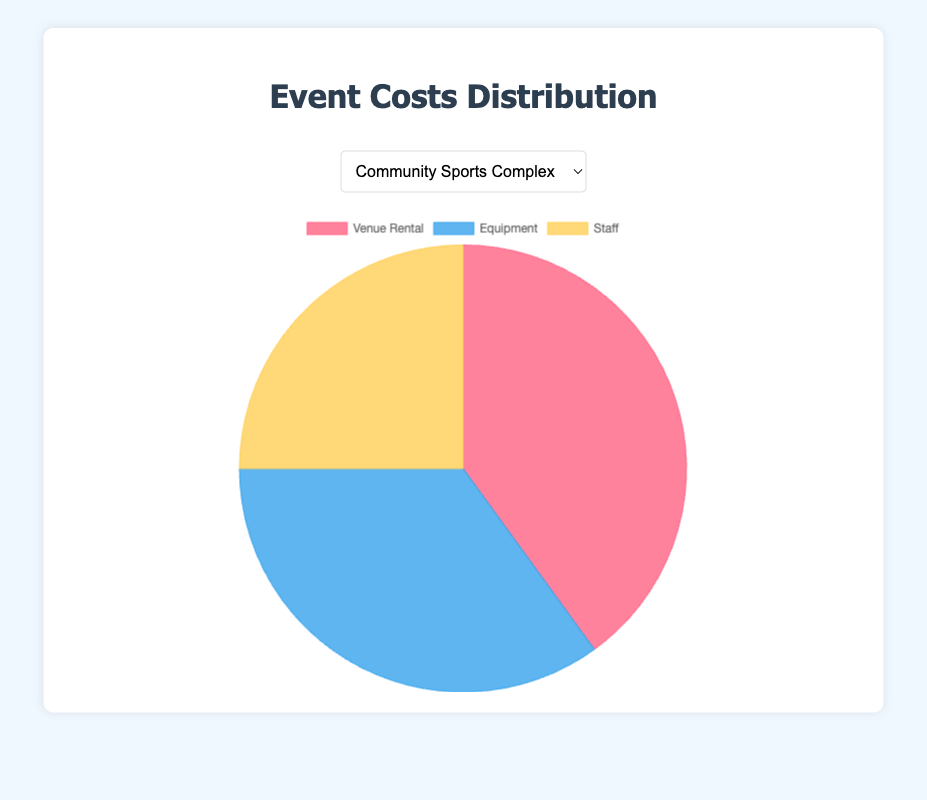What is the most significant cost component for Community Sports Complex? The most significant cost component can be found by looking at the largest percentage in the pie chart for Community Sports Complex. Venue Rental is the largest with 40%.
Answer: Venue Rental What percentage of the costs at Downtown Athletic Park is spent on staff? The percentage of costs spent on staff is directly indicated on the pie chart under 'Staff'. For Downtown Athletic Park, this value is 20%.
Answer: 20% Compare the equipment costs between Riverfront Stadium and City Indoor Arena. Which is higher? The chart shows the percentage for equipment costs for each venue. For Riverfront Stadium, it is 40%, and for City Indoor Arena, it is 20%. 40% is greater than 20%, so Riverfront Stadium has higher equipment costs.
Answer: Riverfront Stadium What is the combined percentage of venue rental and staff costs for Suburban Recreation Center? Add the venue rental percentage (45%) and the staff percentage (30%) for Suburban Recreation Center: 45% + 30% = 75%.
Answer: 75% What is the difference in venue rental costs between Community Sports Complex and Downtown Athletic Park? Subtract the venue rental percentage of Community Sports Complex (40%) from Downtown Athletic Park (50%): 50% - 40% = 10%.
Answer: 10% Which venue has the highest percentage allocated to venue rental? Compare the venue rental percentages across all venues. City Indoor Arena has the highest at 55%.
Answer: City Indoor Arena Which cost category is represented by the blue section in the pie charts? The blue color in the chart corresponds to Equipment, as per the color legend used in the pie charts.
Answer: Equipment What is the least significant cost component for Riverfront Stadium? The least significant cost component is indicated by the smallest percentage. For Riverfront Stadium, this is Staff at 25%.
Answer: Staff Across all venues, which one allocates the highest percentage to staff costs? Compare the staff cost percentages across all venues. Suburban Recreation Center has the highest staff cost percentage at 30%.
Answer: Suburban Recreation Center How does the equipment cost at Community Sports Complex compare to the staff cost at Downtown Athletic Park? Compare the percentages: Equipment cost for Community Sports Complex is 35%, while staff cost at Downtown Athletic Park is 20%. 35% is greater than 20%.
Answer: Community Sports Complex has higher equipment costs 